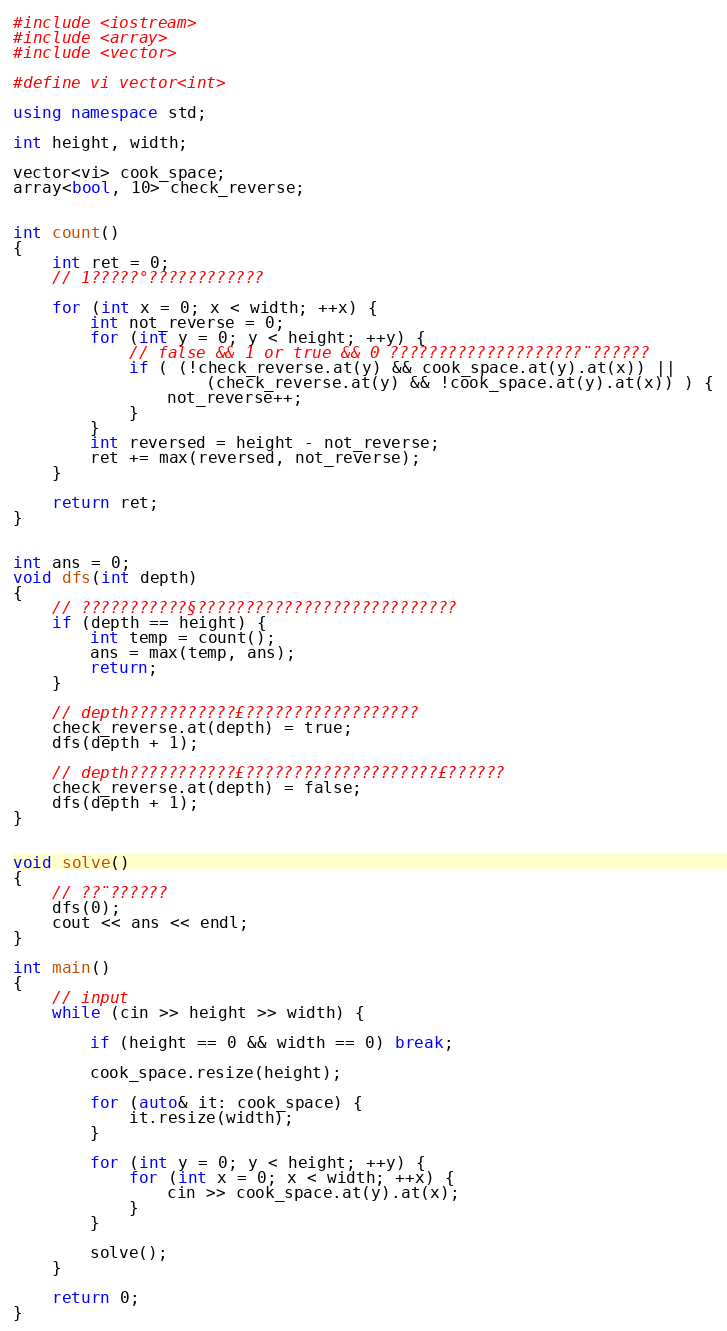Convert code to text. <code><loc_0><loc_0><loc_500><loc_500><_C++_>#include <iostream>
#include <array>
#include <vector>

#define vi vector<int>

using namespace std;

int height, width;

vector<vi> cook_space;
array<bool, 10> check_reverse;


int count()
{
    int ret = 0;
    // 1?????°????????????

    for (int x = 0; x < width; ++x) {
        int not_reverse = 0;
        for (int y = 0; y < height; ++y) {
            // false && 1 or true && 0 ????????????????????¨??????
            if ( (!check_reverse.at(y) && cook_space.at(y).at(x)) ||
                    (check_reverse.at(y) && !cook_space.at(y).at(x)) ) {
                not_reverse++;
            }
        }
        int reversed = height - not_reverse;
        ret += max(reversed, not_reverse);
    }

    return ret;
}


int ans = 0;
void dfs(int depth) 
{
    // ???????????§???????????????????????????
    if (depth == height) {
        int temp = count();
        ans = max(temp, ans);
        return;
    }

    // depth???????????£??????????????????
    check_reverse.at(depth) = true;
    dfs(depth + 1);

    // depth???????????£????????????????????£??????
    check_reverse.at(depth) = false;
    dfs(depth + 1);
}


void solve()
{
    // ??¨??????
    dfs(0);
    cout << ans << endl;
}

int main()
{
    // input
    while (cin >> height >> width) {

        if (height == 0 && width == 0) break;

        cook_space.resize(height);

        for (auto& it: cook_space) {
            it.resize(width);
        }

        for (int y = 0; y < height; ++y) {
            for (int x = 0; x < width; ++x) {
                cin >> cook_space.at(y).at(x);
            }
        }

        solve();
    }

    return 0;
}</code> 